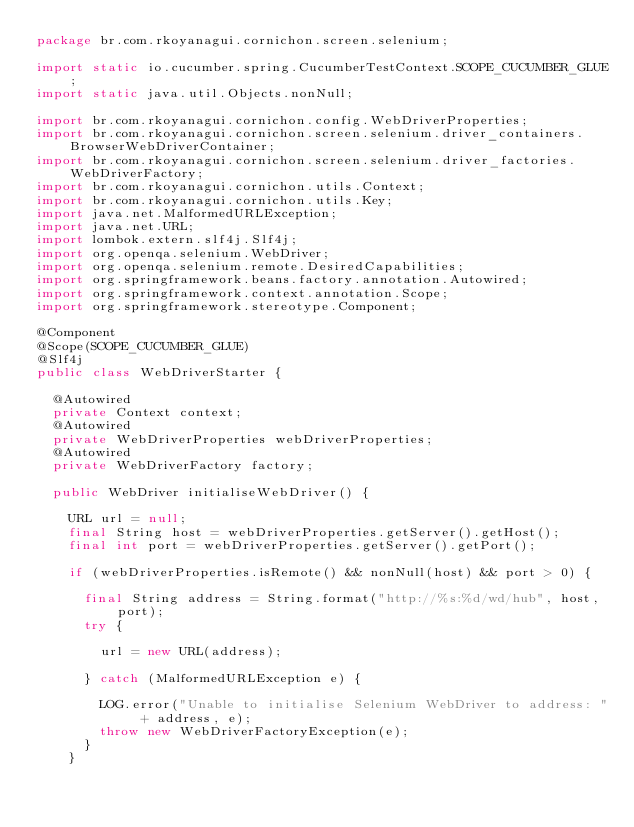Convert code to text. <code><loc_0><loc_0><loc_500><loc_500><_Java_>package br.com.rkoyanagui.cornichon.screen.selenium;

import static io.cucumber.spring.CucumberTestContext.SCOPE_CUCUMBER_GLUE;
import static java.util.Objects.nonNull;

import br.com.rkoyanagui.cornichon.config.WebDriverProperties;
import br.com.rkoyanagui.cornichon.screen.selenium.driver_containers.BrowserWebDriverContainer;
import br.com.rkoyanagui.cornichon.screen.selenium.driver_factories.WebDriverFactory;
import br.com.rkoyanagui.cornichon.utils.Context;
import br.com.rkoyanagui.cornichon.utils.Key;
import java.net.MalformedURLException;
import java.net.URL;
import lombok.extern.slf4j.Slf4j;
import org.openqa.selenium.WebDriver;
import org.openqa.selenium.remote.DesiredCapabilities;
import org.springframework.beans.factory.annotation.Autowired;
import org.springframework.context.annotation.Scope;
import org.springframework.stereotype.Component;

@Component
@Scope(SCOPE_CUCUMBER_GLUE)
@Slf4j
public class WebDriverStarter {

  @Autowired
  private Context context;
  @Autowired
  private WebDriverProperties webDriverProperties;
  @Autowired
  private WebDriverFactory factory;

  public WebDriver initialiseWebDriver() {

    URL url = null;
    final String host = webDriverProperties.getServer().getHost();
    final int port = webDriverProperties.getServer().getPort();

    if (webDriverProperties.isRemote() && nonNull(host) && port > 0) {

      final String address = String.format("http://%s:%d/wd/hub", host, port);
      try {

        url = new URL(address);

      } catch (MalformedURLException e) {

        LOG.error("Unable to initialise Selenium WebDriver to address: " + address, e);
        throw new WebDriverFactoryException(e);
      }
    }</code> 